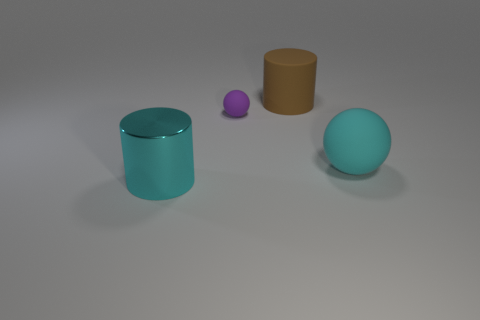Are there any other things that are the same material as the cyan cylinder?
Provide a succinct answer. No. Do the shiny cylinder and the rubber sphere that is right of the brown rubber thing have the same color?
Make the answer very short. Yes. The purple thing that is made of the same material as the large brown cylinder is what size?
Offer a very short reply. Small. Is there a big thing that has the same color as the large matte ball?
Offer a terse response. Yes. How many things are either large cyan shiny objects that are in front of the large brown rubber cylinder or shiny cubes?
Ensure brevity in your answer.  1. Is the material of the cyan cylinder the same as the sphere that is behind the big rubber ball?
Give a very brief answer. No. There is a thing that is the same color as the big metallic cylinder; what size is it?
Give a very brief answer. Large. Are there any purple things that have the same material as the brown cylinder?
Keep it short and to the point. Yes. How many objects are spheres that are right of the purple rubber thing or rubber balls that are to the right of the tiny purple ball?
Give a very brief answer. 1. There is a small purple matte thing; does it have the same shape as the large brown matte thing on the right side of the cyan shiny cylinder?
Offer a terse response. No. 